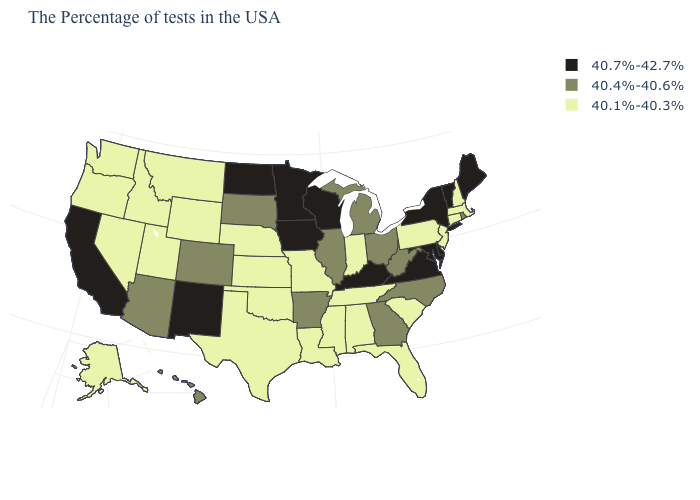Among the states that border Indiana , does Ohio have the lowest value?
Write a very short answer. Yes. What is the value of Vermont?
Answer briefly. 40.7%-42.7%. Name the states that have a value in the range 40.1%-40.3%?
Be succinct. Massachusetts, New Hampshire, Connecticut, New Jersey, Pennsylvania, South Carolina, Florida, Indiana, Alabama, Tennessee, Mississippi, Louisiana, Missouri, Kansas, Nebraska, Oklahoma, Texas, Wyoming, Utah, Montana, Idaho, Nevada, Washington, Oregon, Alaska. Does Wisconsin have the highest value in the USA?
Write a very short answer. Yes. Does the first symbol in the legend represent the smallest category?
Give a very brief answer. No. What is the value of Florida?
Quick response, please. 40.1%-40.3%. Name the states that have a value in the range 40.4%-40.6%?
Quick response, please. Rhode Island, North Carolina, West Virginia, Ohio, Georgia, Michigan, Illinois, Arkansas, South Dakota, Colorado, Arizona, Hawaii. Does the map have missing data?
Short answer required. No. How many symbols are there in the legend?
Be succinct. 3. Does the map have missing data?
Concise answer only. No. Does Hawaii have the same value as Minnesota?
Quick response, please. No. Name the states that have a value in the range 40.4%-40.6%?
Be succinct. Rhode Island, North Carolina, West Virginia, Ohio, Georgia, Michigan, Illinois, Arkansas, South Dakota, Colorado, Arizona, Hawaii. Name the states that have a value in the range 40.7%-42.7%?
Answer briefly. Maine, Vermont, New York, Delaware, Maryland, Virginia, Kentucky, Wisconsin, Minnesota, Iowa, North Dakota, New Mexico, California. Among the states that border Rhode Island , which have the highest value?
Answer briefly. Massachusetts, Connecticut. Which states have the lowest value in the Northeast?
Give a very brief answer. Massachusetts, New Hampshire, Connecticut, New Jersey, Pennsylvania. 